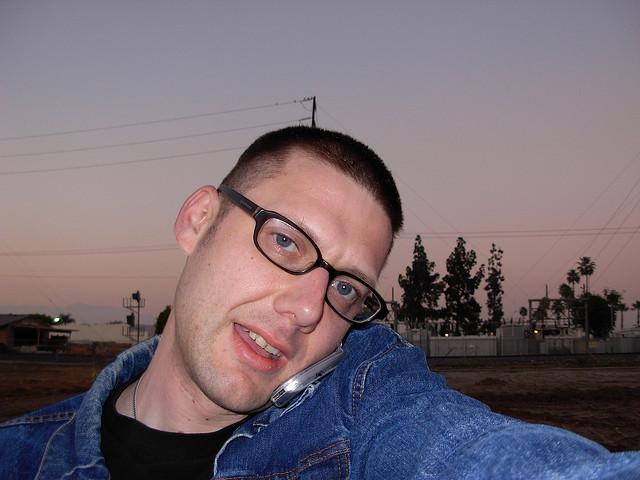What color is the man's shirt?
Keep it brief. Black. Is he using a selfie stick?
Be succinct. No. What is ironic about this photo?
Short answer required. Nothing. What is the man wearing on his head?
Be succinct. Glasses. Why is the man's head tilted?
Quick response, please. On phone. What is in the background?
Answer briefly. Trees. Is the man hungry?
Be succinct. No. Where is this man?
Concise answer only. Outside. Did this man shave this morning?
Keep it brief. Yes. 